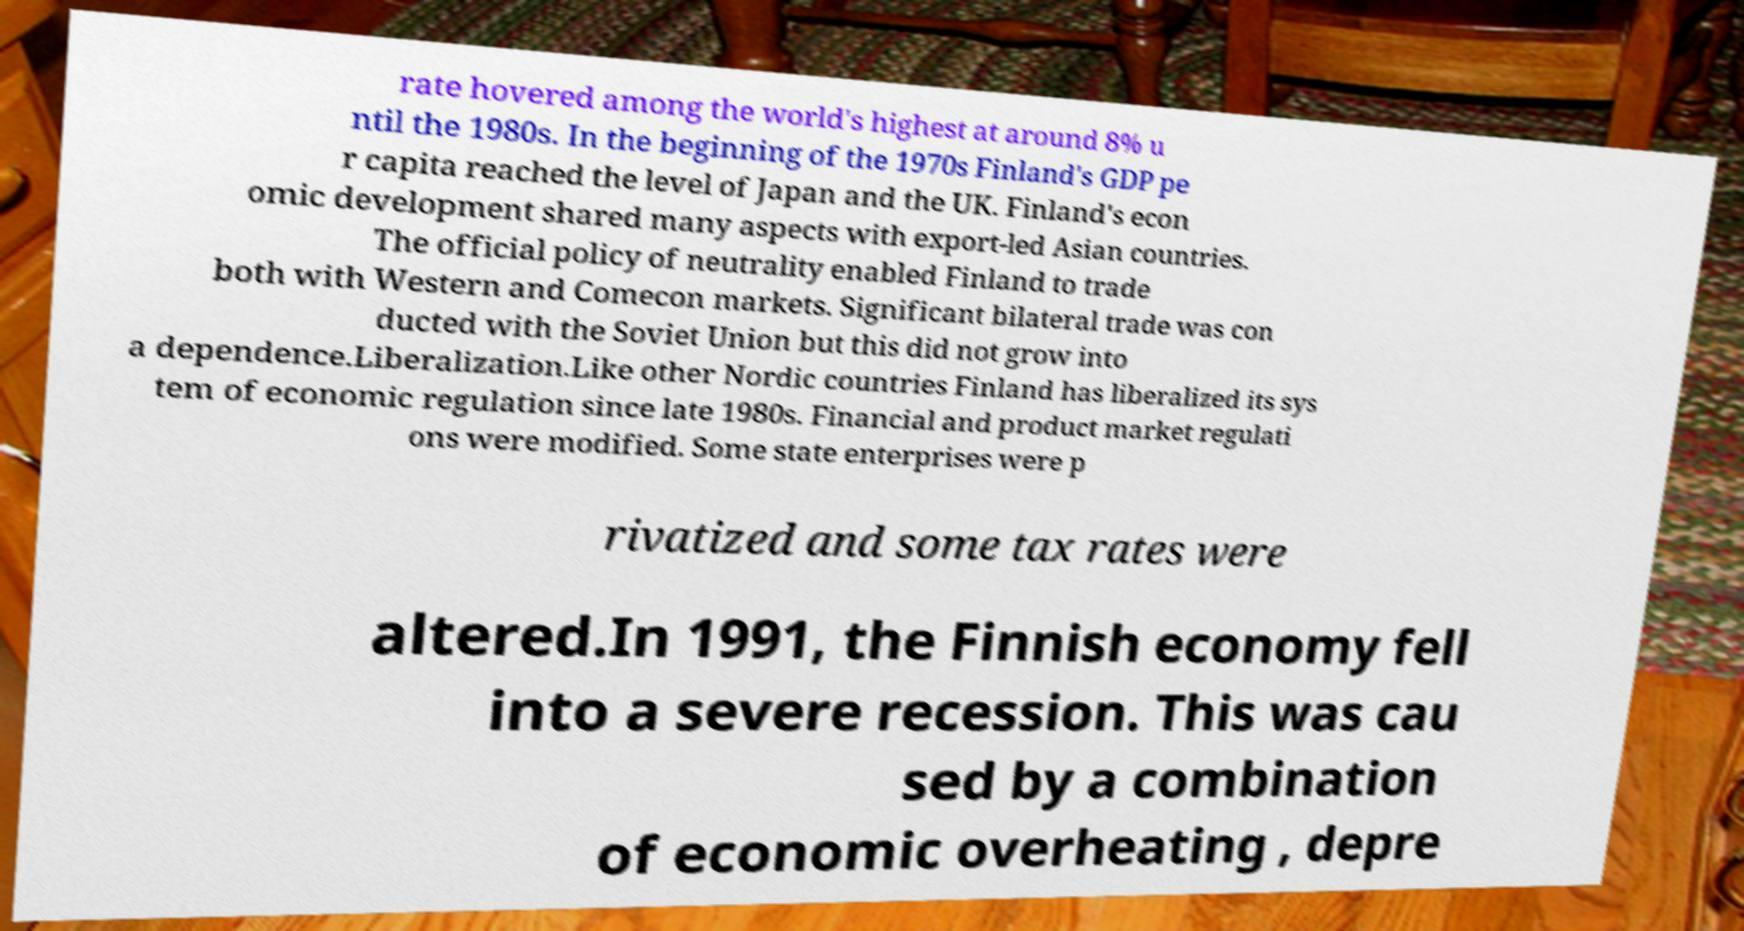Please identify and transcribe the text found in this image. rate hovered among the world's highest at around 8% u ntil the 1980s. In the beginning of the 1970s Finland's GDP pe r capita reached the level of Japan and the UK. Finland's econ omic development shared many aspects with export-led Asian countries. The official policy of neutrality enabled Finland to trade both with Western and Comecon markets. Significant bilateral trade was con ducted with the Soviet Union but this did not grow into a dependence.Liberalization.Like other Nordic countries Finland has liberalized its sys tem of economic regulation since late 1980s. Financial and product market regulati ons were modified. Some state enterprises were p rivatized and some tax rates were altered.In 1991, the Finnish economy fell into a severe recession. This was cau sed by a combination of economic overheating , depre 